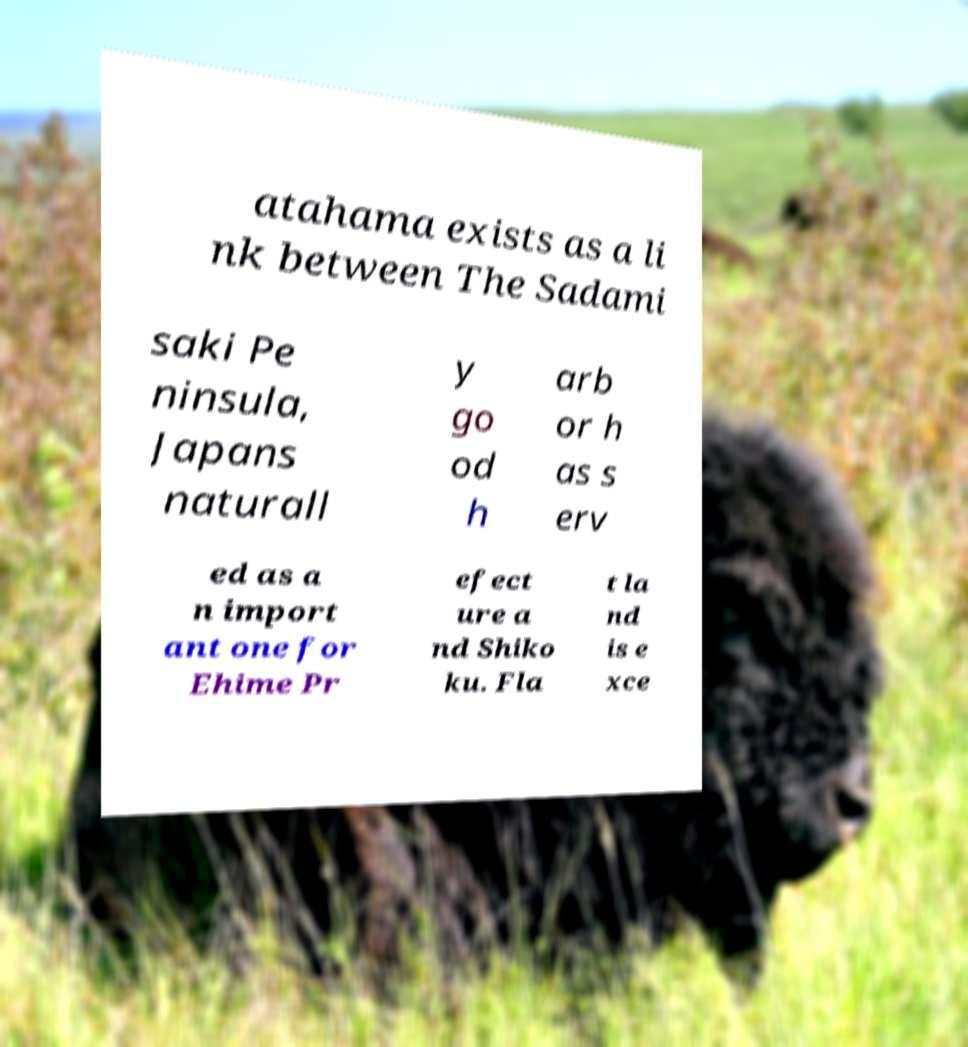What messages or text are displayed in this image? I need them in a readable, typed format. atahama exists as a li nk between The Sadami saki Pe ninsula, Japans naturall y go od h arb or h as s erv ed as a n import ant one for Ehime Pr efect ure a nd Shiko ku. Fla t la nd is e xce 